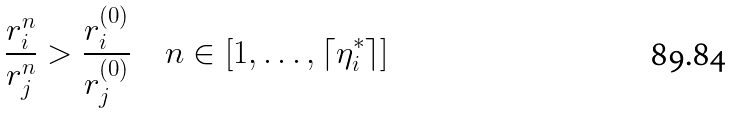Convert formula to latex. <formula><loc_0><loc_0><loc_500><loc_500>\frac { r ^ { n } _ { i } } { r ^ { n } _ { j } } > \frac { r ^ { ( 0 ) } _ { i } } { r ^ { ( 0 ) } _ { j } } \quad n \in [ 1 , \dots , \lceil \eta ^ { * } _ { i } \rceil ]</formula> 